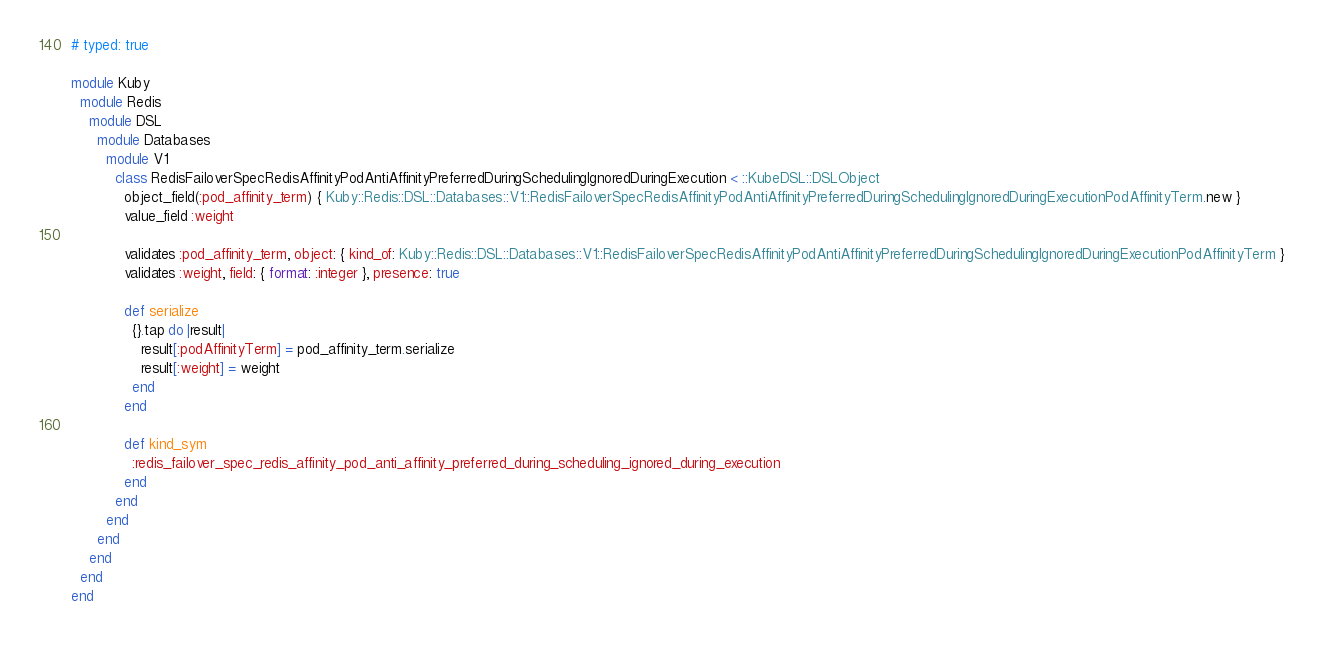Convert code to text. <code><loc_0><loc_0><loc_500><loc_500><_Ruby_># typed: true

module Kuby
  module Redis
    module DSL
      module Databases
        module V1
          class RedisFailoverSpecRedisAffinityPodAntiAffinityPreferredDuringSchedulingIgnoredDuringExecution < ::KubeDSL::DSLObject
            object_field(:pod_affinity_term) { Kuby::Redis::DSL::Databases::V1::RedisFailoverSpecRedisAffinityPodAntiAffinityPreferredDuringSchedulingIgnoredDuringExecutionPodAffinityTerm.new }
            value_field :weight

            validates :pod_affinity_term, object: { kind_of: Kuby::Redis::DSL::Databases::V1::RedisFailoverSpecRedisAffinityPodAntiAffinityPreferredDuringSchedulingIgnoredDuringExecutionPodAffinityTerm }
            validates :weight, field: { format: :integer }, presence: true

            def serialize
              {}.tap do |result|
                result[:podAffinityTerm] = pod_affinity_term.serialize
                result[:weight] = weight
              end
            end

            def kind_sym
              :redis_failover_spec_redis_affinity_pod_anti_affinity_preferred_during_scheduling_ignored_during_execution
            end
          end
        end
      end
    end
  end
end</code> 